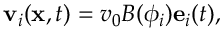Convert formula to latex. <formula><loc_0><loc_0><loc_500><loc_500>v _ { i } ( x , t ) = v _ { 0 } B ( \phi _ { i } ) e _ { i } ( t ) ,</formula> 